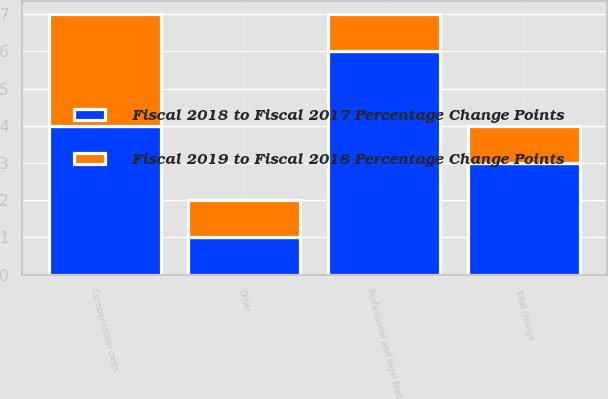<chart> <loc_0><loc_0><loc_500><loc_500><stacked_bar_chart><ecel><fcel>Compensation costs<fcel>Professional and legal fees<fcel>Other<fcel>Total change<nl><fcel>Fiscal 2019 to Fiscal 2018 Percentage Change Points<fcel>3<fcel>1<fcel>1<fcel>1<nl><fcel>Fiscal 2018 to Fiscal 2017 Percentage Change Points<fcel>4<fcel>6<fcel>1<fcel>3<nl></chart> 